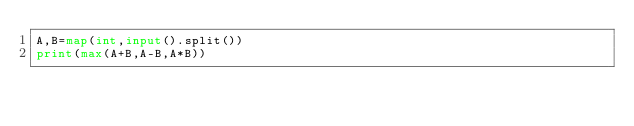<code> <loc_0><loc_0><loc_500><loc_500><_Python_>A,B=map(int,input().split())
print(max(A+B,A-B,A*B))
</code> 